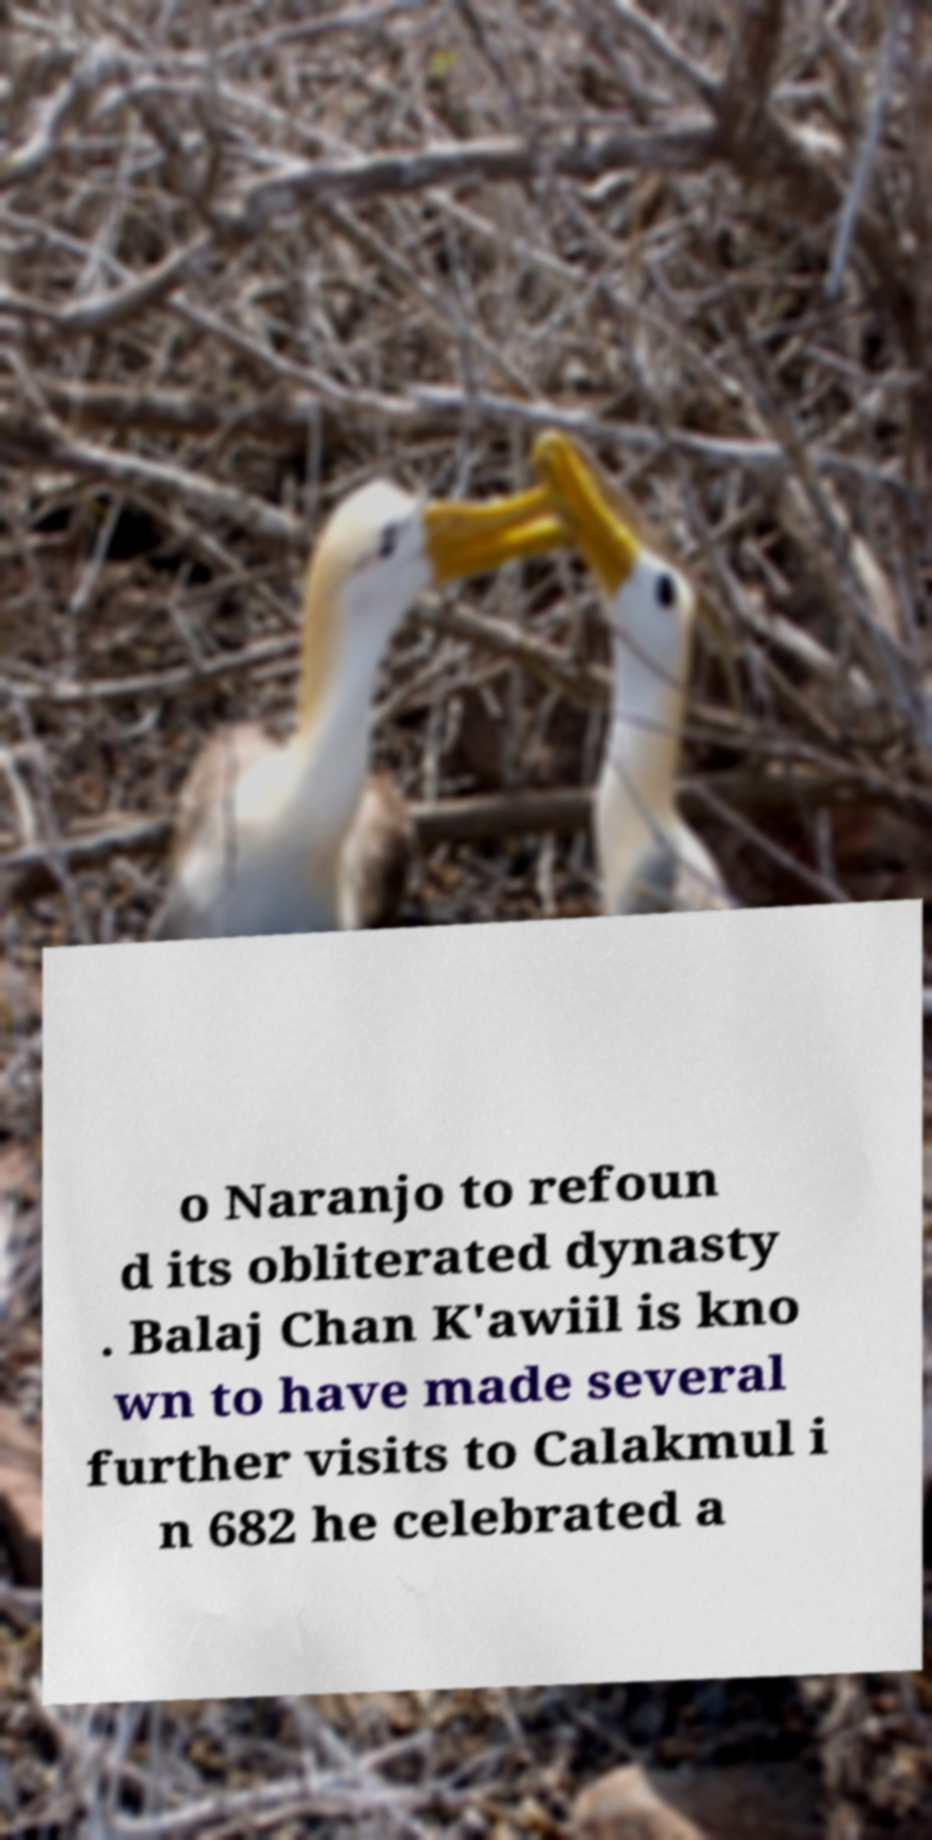Can you accurately transcribe the text from the provided image for me? o Naranjo to refoun d its obliterated dynasty . Balaj Chan K'awiil is kno wn to have made several further visits to Calakmul i n 682 he celebrated a 